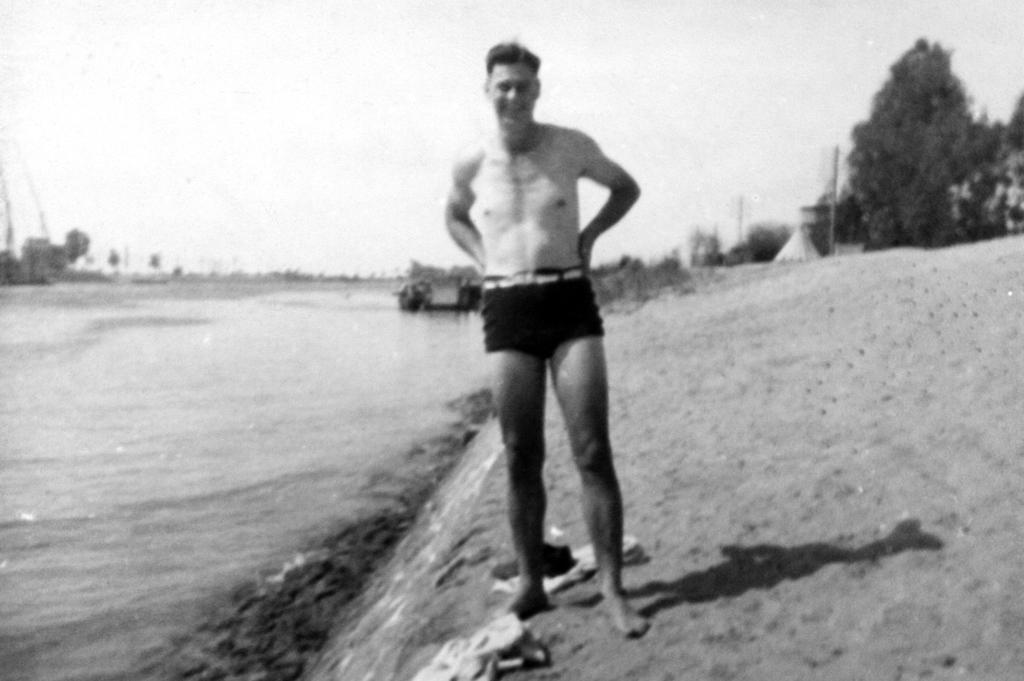What is the main subject of the image? There is a man standing in the image. What can be seen on the left side of the image? There is water on the left side of the image. What is visible in the background of the image? There are trees and the sky visible in the background of the image. What objects are present in the image besides the man? There are poles in the image. What type of bean is growing on the poles in the image? There are no beans present in the image, and the poles do not have any plants growing on them. 